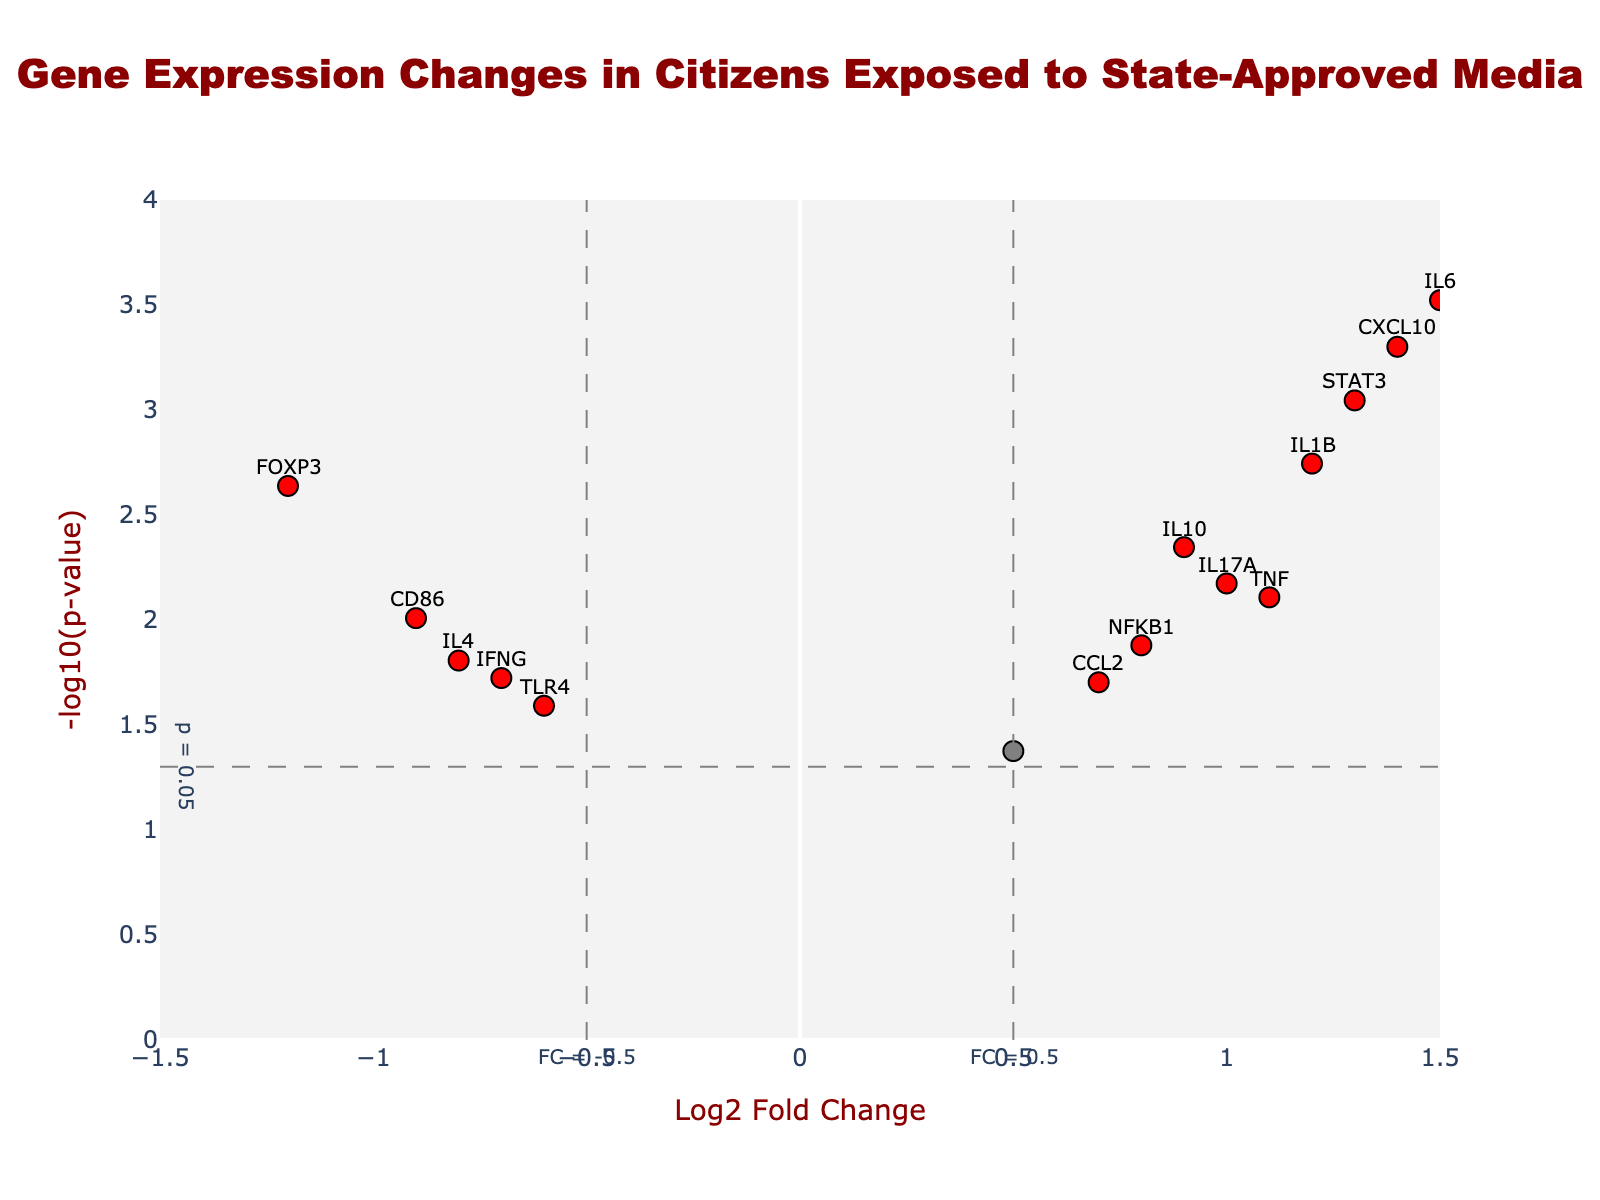How many genes are labeled as significant in the plot? To find the significant genes, look for those marked in red. Count the number of red dots on the plot.
Answer: 11 What is the Log2 Fold Change value for the gene IL6? Locate IL6 on the plot by hovering over it or finding its annotation. The Log2 Fold Change value is next to its name.
Answer: 1.5 Which gene has the lowest p-value? The gene with the lowest p-value will have the highest -log10(p-value). Check the highest points and identify them.
Answer: IL6 How many genes fall below the Log2 Fold Change threshold of 0.5? Identify the genes within the range of -0.5 < Log2 Fold Change < 0.5 by checking the plot. Count all the dots within these thresholds.
Answer: 2 Which gene shows the most significant upregulation? Determine upregulated genes by looking at positive Log2 Fold Change values. Among these, find the dot with the highest -log10(p-value).
Answer: IL6 Compare the expression changes for genes IFNG and TNF. Which one is more significant? Compare the -log10(p-value) values for IFNG and TNF. The gene with the higher value is more significant.
Answer: TNF For the gene IL4, what is its significance level based on the p-value? Find the IL4 gene on the plot by its annotation. Check its -log10(p-value), then convert this to a p-value. Locate it in terms of significance, where significant p-value < 0.05.
Answer: Significant Among the genes downregulated, which one has the smallest Log2 Fold Change value? Identify genes with negative Log2 Fold Change values, then find the smallest Log2 Fold Change among them.
Answer: FOXP3 Calculate the difference in -log10(p-value) between genes IL10 and IL1B. Locate both genes and note their -log10(p-value) values. Subtract the lower from the higher value.
Answer: 1.1803 Are there more upregulated or downregulated genes that are considered significant? Significant genes are marked in red. Count the red dots in positive Log2 Fold Change (upregulated) and negative Log2 Fold Change (downregulated) regions. Compare the counts.
Answer: More upregulated 